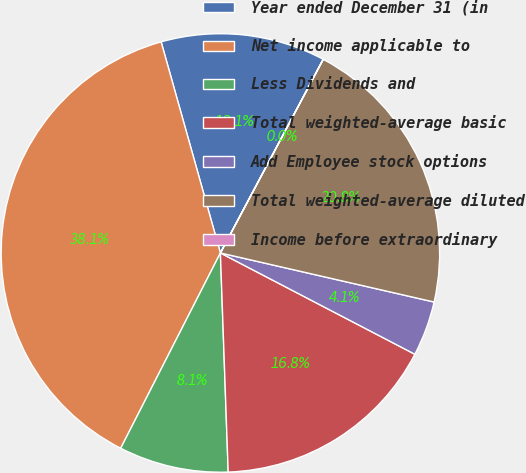Convert chart. <chart><loc_0><loc_0><loc_500><loc_500><pie_chart><fcel>Year ended December 31 (in<fcel>Net income applicable to<fcel>Less Dividends and<fcel>Total weighted-average basic<fcel>Add Employee stock options<fcel>Total weighted-average diluted<fcel>Income before extraordinary<nl><fcel>12.12%<fcel>38.13%<fcel>8.08%<fcel>16.79%<fcel>4.05%<fcel>20.82%<fcel>0.01%<nl></chart> 